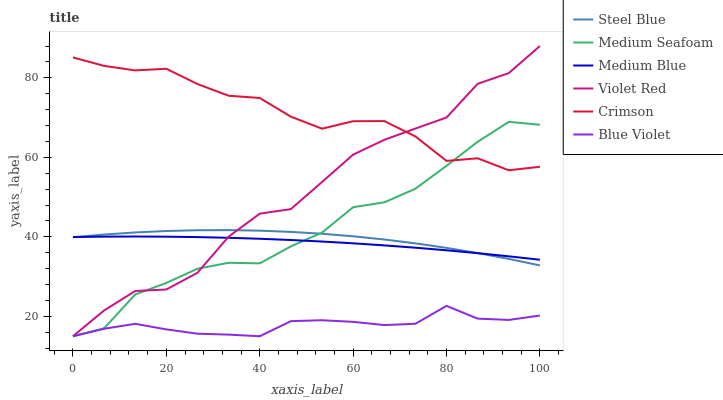Does Blue Violet have the minimum area under the curve?
Answer yes or no. Yes. Does Crimson have the maximum area under the curve?
Answer yes or no. Yes. Does Medium Blue have the minimum area under the curve?
Answer yes or no. No. Does Medium Blue have the maximum area under the curve?
Answer yes or no. No. Is Medium Blue the smoothest?
Answer yes or no. Yes. Is Violet Red the roughest?
Answer yes or no. Yes. Is Steel Blue the smoothest?
Answer yes or no. No. Is Steel Blue the roughest?
Answer yes or no. No. Does Violet Red have the lowest value?
Answer yes or no. Yes. Does Medium Blue have the lowest value?
Answer yes or no. No. Does Violet Red have the highest value?
Answer yes or no. Yes. Does Medium Blue have the highest value?
Answer yes or no. No. Is Blue Violet less than Medium Blue?
Answer yes or no. Yes. Is Medium Blue greater than Blue Violet?
Answer yes or no. Yes. Does Crimson intersect Medium Seafoam?
Answer yes or no. Yes. Is Crimson less than Medium Seafoam?
Answer yes or no. No. Is Crimson greater than Medium Seafoam?
Answer yes or no. No. Does Blue Violet intersect Medium Blue?
Answer yes or no. No. 